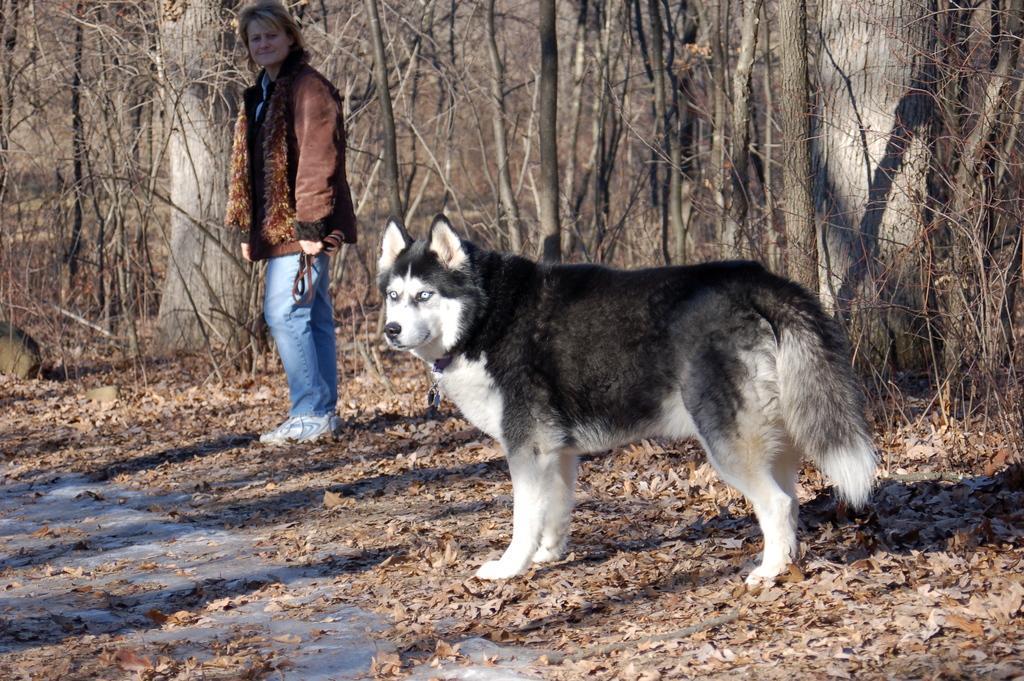Describe this image in one or two sentences. There is a dog. In the back there's a lady wearing jacket and holding a belt. On the ground there are leaves. In the back there are trees. 